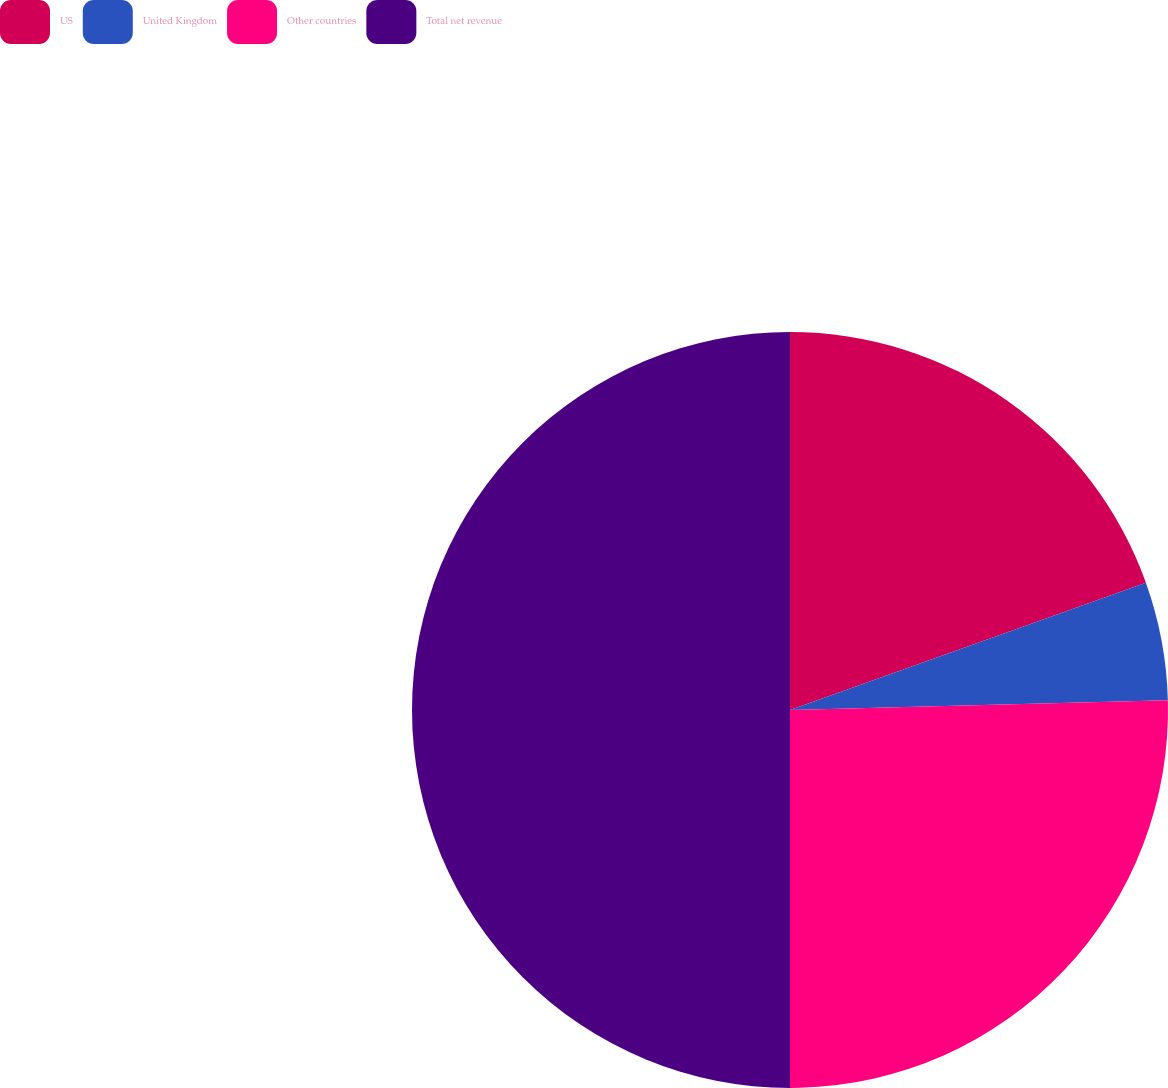Convert chart to OTSL. <chart><loc_0><loc_0><loc_500><loc_500><pie_chart><fcel>US<fcel>United Kingdom<fcel>Other countries<fcel>Total net revenue<nl><fcel>19.53%<fcel>5.06%<fcel>25.41%<fcel>50.0%<nl></chart> 